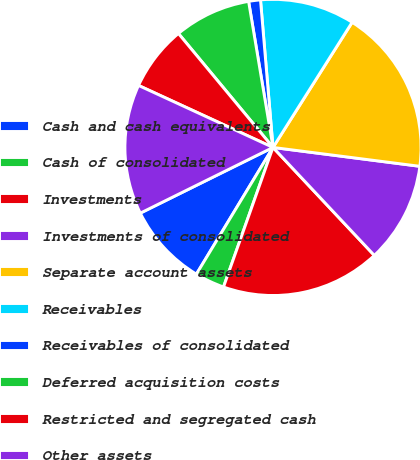Convert chart. <chart><loc_0><loc_0><loc_500><loc_500><pie_chart><fcel>Cash and cash equivalents<fcel>Cash of consolidated<fcel>Investments<fcel>Investments of consolidated<fcel>Separate account assets<fcel>Receivables<fcel>Receivables of consolidated<fcel>Deferred acquisition costs<fcel>Restricted and segregated cash<fcel>Other assets<nl><fcel>9.03%<fcel>3.23%<fcel>17.42%<fcel>10.97%<fcel>18.06%<fcel>10.32%<fcel>1.29%<fcel>8.39%<fcel>7.1%<fcel>14.19%<nl></chart> 